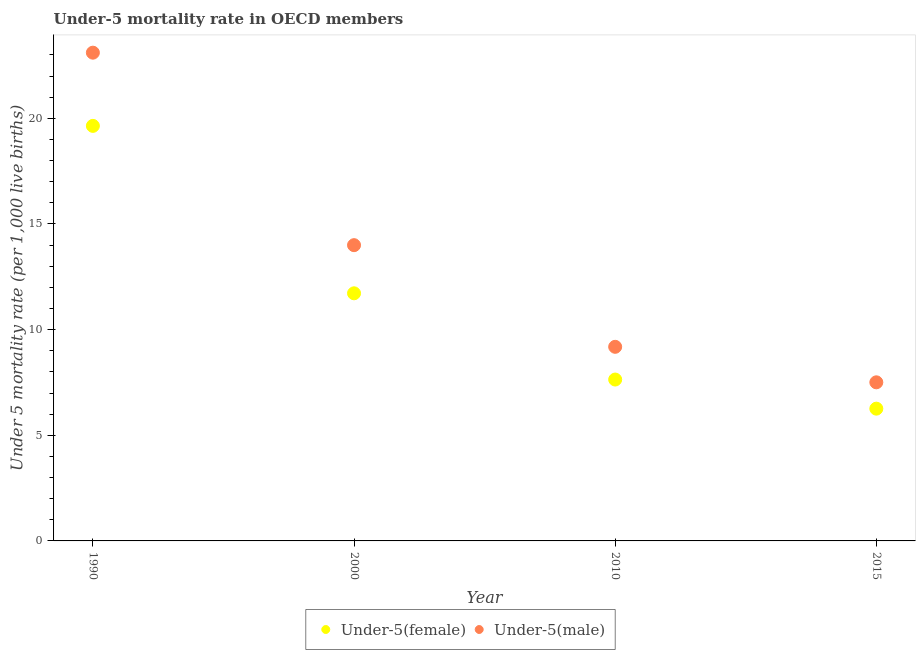How many different coloured dotlines are there?
Provide a succinct answer. 2. What is the under-5 female mortality rate in 1990?
Ensure brevity in your answer.  19.64. Across all years, what is the maximum under-5 male mortality rate?
Your answer should be compact. 23.11. Across all years, what is the minimum under-5 female mortality rate?
Provide a succinct answer. 6.26. In which year was the under-5 male mortality rate maximum?
Provide a short and direct response. 1990. In which year was the under-5 male mortality rate minimum?
Ensure brevity in your answer.  2015. What is the total under-5 female mortality rate in the graph?
Ensure brevity in your answer.  45.26. What is the difference between the under-5 male mortality rate in 2000 and that in 2010?
Ensure brevity in your answer.  4.81. What is the difference between the under-5 female mortality rate in 2000 and the under-5 male mortality rate in 2015?
Your response must be concise. 4.21. What is the average under-5 male mortality rate per year?
Your answer should be very brief. 13.45. In the year 2010, what is the difference between the under-5 female mortality rate and under-5 male mortality rate?
Offer a terse response. -1.55. What is the ratio of the under-5 male mortality rate in 2000 to that in 2015?
Ensure brevity in your answer.  1.86. What is the difference between the highest and the second highest under-5 male mortality rate?
Make the answer very short. 9.11. What is the difference between the highest and the lowest under-5 male mortality rate?
Provide a short and direct response. 15.6. Does the under-5 female mortality rate monotonically increase over the years?
Your answer should be very brief. No. Is the under-5 female mortality rate strictly greater than the under-5 male mortality rate over the years?
Offer a very short reply. No. Is the under-5 female mortality rate strictly less than the under-5 male mortality rate over the years?
Provide a short and direct response. Yes. How many dotlines are there?
Your answer should be compact. 2. How many years are there in the graph?
Provide a short and direct response. 4. What is the difference between two consecutive major ticks on the Y-axis?
Make the answer very short. 5. Are the values on the major ticks of Y-axis written in scientific E-notation?
Ensure brevity in your answer.  No. Does the graph contain grids?
Your answer should be very brief. No. What is the title of the graph?
Provide a succinct answer. Under-5 mortality rate in OECD members. What is the label or title of the X-axis?
Provide a succinct answer. Year. What is the label or title of the Y-axis?
Offer a terse response. Under 5 mortality rate (per 1,0 live births). What is the Under 5 mortality rate (per 1,000 live births) in Under-5(female) in 1990?
Provide a short and direct response. 19.64. What is the Under 5 mortality rate (per 1,000 live births) in Under-5(male) in 1990?
Make the answer very short. 23.11. What is the Under 5 mortality rate (per 1,000 live births) of Under-5(female) in 2000?
Give a very brief answer. 11.72. What is the Under 5 mortality rate (per 1,000 live births) in Under-5(male) in 2000?
Keep it short and to the point. 14. What is the Under 5 mortality rate (per 1,000 live births) in Under-5(female) in 2010?
Give a very brief answer. 7.64. What is the Under 5 mortality rate (per 1,000 live births) of Under-5(male) in 2010?
Make the answer very short. 9.19. What is the Under 5 mortality rate (per 1,000 live births) in Under-5(female) in 2015?
Make the answer very short. 6.26. What is the Under 5 mortality rate (per 1,000 live births) in Under-5(male) in 2015?
Provide a short and direct response. 7.51. Across all years, what is the maximum Under 5 mortality rate (per 1,000 live births) of Under-5(female)?
Offer a very short reply. 19.64. Across all years, what is the maximum Under 5 mortality rate (per 1,000 live births) of Under-5(male)?
Give a very brief answer. 23.11. Across all years, what is the minimum Under 5 mortality rate (per 1,000 live births) of Under-5(female)?
Your answer should be compact. 6.26. Across all years, what is the minimum Under 5 mortality rate (per 1,000 live births) of Under-5(male)?
Your answer should be very brief. 7.51. What is the total Under 5 mortality rate (per 1,000 live births) of Under-5(female) in the graph?
Make the answer very short. 45.26. What is the total Under 5 mortality rate (per 1,000 live births) of Under-5(male) in the graph?
Keep it short and to the point. 53.8. What is the difference between the Under 5 mortality rate (per 1,000 live births) of Under-5(female) in 1990 and that in 2000?
Offer a very short reply. 7.92. What is the difference between the Under 5 mortality rate (per 1,000 live births) in Under-5(male) in 1990 and that in 2000?
Your answer should be compact. 9.11. What is the difference between the Under 5 mortality rate (per 1,000 live births) in Under-5(female) in 1990 and that in 2010?
Your answer should be compact. 12.01. What is the difference between the Under 5 mortality rate (per 1,000 live births) in Under-5(male) in 1990 and that in 2010?
Ensure brevity in your answer.  13.92. What is the difference between the Under 5 mortality rate (per 1,000 live births) in Under-5(female) in 1990 and that in 2015?
Provide a succinct answer. 13.38. What is the difference between the Under 5 mortality rate (per 1,000 live births) of Under-5(male) in 1990 and that in 2015?
Your answer should be very brief. 15.6. What is the difference between the Under 5 mortality rate (per 1,000 live births) of Under-5(female) in 2000 and that in 2010?
Provide a short and direct response. 4.08. What is the difference between the Under 5 mortality rate (per 1,000 live births) of Under-5(male) in 2000 and that in 2010?
Provide a succinct answer. 4.81. What is the difference between the Under 5 mortality rate (per 1,000 live births) in Under-5(female) in 2000 and that in 2015?
Offer a very short reply. 5.46. What is the difference between the Under 5 mortality rate (per 1,000 live births) in Under-5(male) in 2000 and that in 2015?
Give a very brief answer. 6.49. What is the difference between the Under 5 mortality rate (per 1,000 live births) of Under-5(female) in 2010 and that in 2015?
Ensure brevity in your answer.  1.38. What is the difference between the Under 5 mortality rate (per 1,000 live births) in Under-5(male) in 2010 and that in 2015?
Give a very brief answer. 1.68. What is the difference between the Under 5 mortality rate (per 1,000 live births) in Under-5(female) in 1990 and the Under 5 mortality rate (per 1,000 live births) in Under-5(male) in 2000?
Your response must be concise. 5.65. What is the difference between the Under 5 mortality rate (per 1,000 live births) in Under-5(female) in 1990 and the Under 5 mortality rate (per 1,000 live births) in Under-5(male) in 2010?
Offer a terse response. 10.46. What is the difference between the Under 5 mortality rate (per 1,000 live births) of Under-5(female) in 1990 and the Under 5 mortality rate (per 1,000 live births) of Under-5(male) in 2015?
Give a very brief answer. 12.14. What is the difference between the Under 5 mortality rate (per 1,000 live births) in Under-5(female) in 2000 and the Under 5 mortality rate (per 1,000 live births) in Under-5(male) in 2010?
Ensure brevity in your answer.  2.53. What is the difference between the Under 5 mortality rate (per 1,000 live births) in Under-5(female) in 2000 and the Under 5 mortality rate (per 1,000 live births) in Under-5(male) in 2015?
Ensure brevity in your answer.  4.21. What is the difference between the Under 5 mortality rate (per 1,000 live births) of Under-5(female) in 2010 and the Under 5 mortality rate (per 1,000 live births) of Under-5(male) in 2015?
Your answer should be compact. 0.13. What is the average Under 5 mortality rate (per 1,000 live births) of Under-5(female) per year?
Give a very brief answer. 11.32. What is the average Under 5 mortality rate (per 1,000 live births) of Under-5(male) per year?
Make the answer very short. 13.45. In the year 1990, what is the difference between the Under 5 mortality rate (per 1,000 live births) of Under-5(female) and Under 5 mortality rate (per 1,000 live births) of Under-5(male)?
Give a very brief answer. -3.46. In the year 2000, what is the difference between the Under 5 mortality rate (per 1,000 live births) in Under-5(female) and Under 5 mortality rate (per 1,000 live births) in Under-5(male)?
Keep it short and to the point. -2.28. In the year 2010, what is the difference between the Under 5 mortality rate (per 1,000 live births) in Under-5(female) and Under 5 mortality rate (per 1,000 live births) in Under-5(male)?
Offer a very short reply. -1.55. In the year 2015, what is the difference between the Under 5 mortality rate (per 1,000 live births) in Under-5(female) and Under 5 mortality rate (per 1,000 live births) in Under-5(male)?
Offer a terse response. -1.25. What is the ratio of the Under 5 mortality rate (per 1,000 live births) of Under-5(female) in 1990 to that in 2000?
Your answer should be compact. 1.68. What is the ratio of the Under 5 mortality rate (per 1,000 live births) in Under-5(male) in 1990 to that in 2000?
Give a very brief answer. 1.65. What is the ratio of the Under 5 mortality rate (per 1,000 live births) of Under-5(female) in 1990 to that in 2010?
Ensure brevity in your answer.  2.57. What is the ratio of the Under 5 mortality rate (per 1,000 live births) in Under-5(male) in 1990 to that in 2010?
Make the answer very short. 2.52. What is the ratio of the Under 5 mortality rate (per 1,000 live births) of Under-5(female) in 1990 to that in 2015?
Make the answer very short. 3.14. What is the ratio of the Under 5 mortality rate (per 1,000 live births) in Under-5(male) in 1990 to that in 2015?
Give a very brief answer. 3.08. What is the ratio of the Under 5 mortality rate (per 1,000 live births) of Under-5(female) in 2000 to that in 2010?
Your response must be concise. 1.53. What is the ratio of the Under 5 mortality rate (per 1,000 live births) of Under-5(male) in 2000 to that in 2010?
Offer a very short reply. 1.52. What is the ratio of the Under 5 mortality rate (per 1,000 live births) in Under-5(female) in 2000 to that in 2015?
Provide a short and direct response. 1.87. What is the ratio of the Under 5 mortality rate (per 1,000 live births) of Under-5(male) in 2000 to that in 2015?
Your answer should be very brief. 1.86. What is the ratio of the Under 5 mortality rate (per 1,000 live births) of Under-5(female) in 2010 to that in 2015?
Make the answer very short. 1.22. What is the ratio of the Under 5 mortality rate (per 1,000 live births) in Under-5(male) in 2010 to that in 2015?
Offer a terse response. 1.22. What is the difference between the highest and the second highest Under 5 mortality rate (per 1,000 live births) of Under-5(female)?
Offer a very short reply. 7.92. What is the difference between the highest and the second highest Under 5 mortality rate (per 1,000 live births) of Under-5(male)?
Offer a terse response. 9.11. What is the difference between the highest and the lowest Under 5 mortality rate (per 1,000 live births) in Under-5(female)?
Your response must be concise. 13.38. What is the difference between the highest and the lowest Under 5 mortality rate (per 1,000 live births) of Under-5(male)?
Keep it short and to the point. 15.6. 